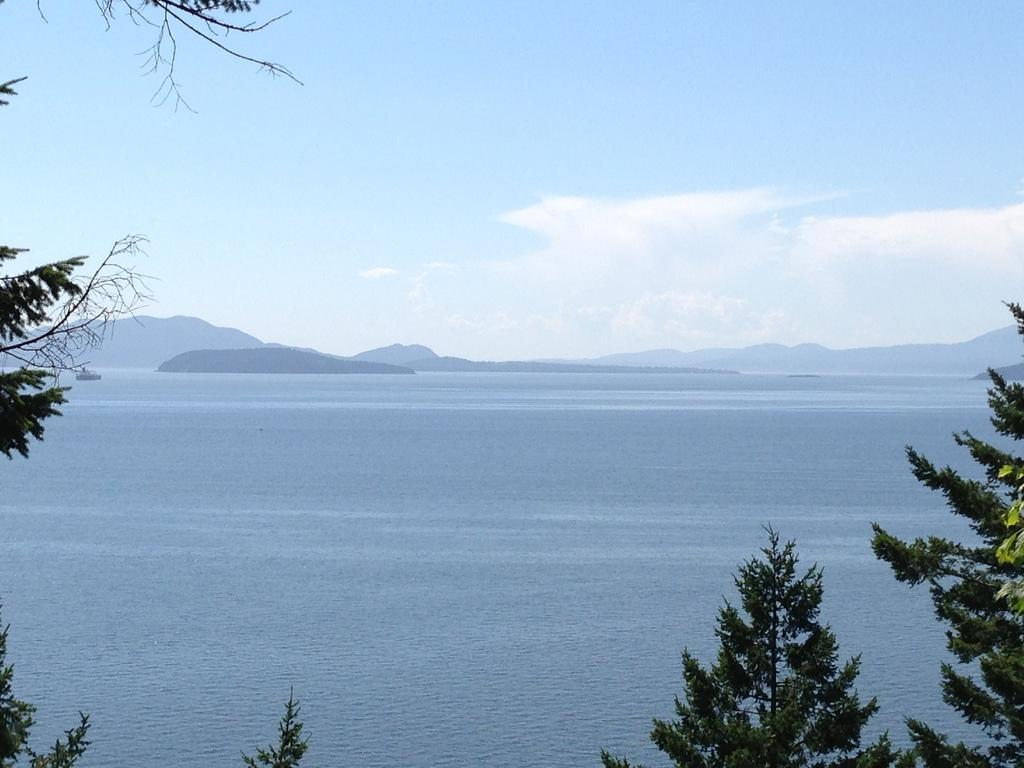What type of living organisms can be seen in the image? Plants can be seen in the image. What is the other main object in the image? There is an object in the image, but its specific nature is not mentioned in the facts. What natural element is visible in the image? Water is visible in the image. What type of geographical feature can be seen in the image? Mountains are visible in the image. What is the weather like in the image? The sky is cloudy in the image. What type of drug is being administered to the heart in the image? There is no mention of a heart or any drug in the image; it features plants, an object, water, mountains, and a cloudy sky. 